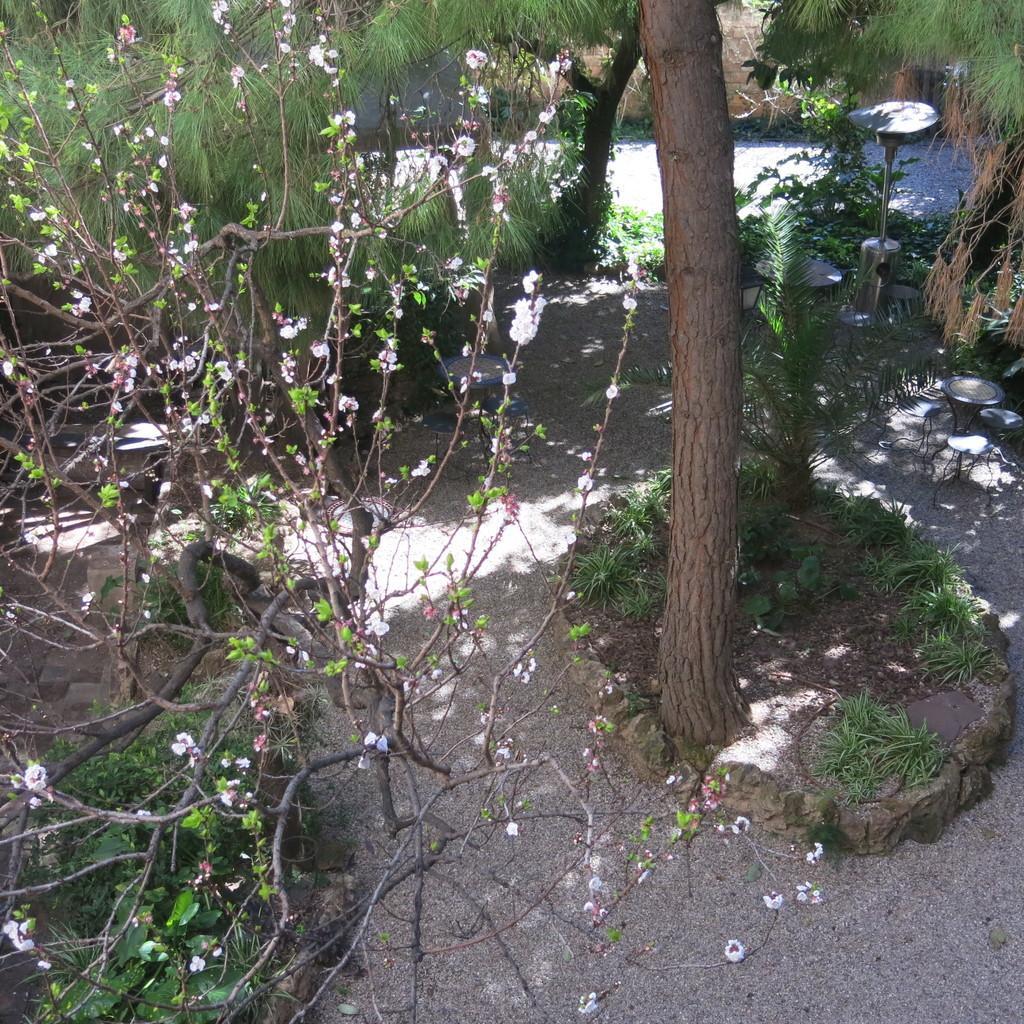How would you summarize this image in a sentence or two? Here in this picture we can see grass, plants and trees present on the ground and we can see flowers present on the plant in the front. 